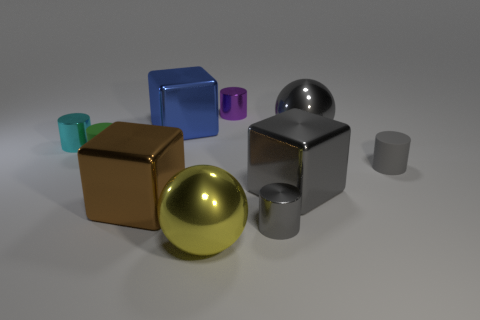There is a big shiny cube that is on the right side of the purple cylinder; does it have the same color as the small shiny thing that is right of the small purple object?
Provide a succinct answer. Yes. Is the big blue metallic object the same shape as the brown thing?
Ensure brevity in your answer.  Yes. Is the material of the big ball in front of the gray metallic sphere the same as the large brown block?
Offer a very short reply. Yes. There is a tiny metal thing that is to the right of the tiny green matte cylinder and in front of the purple metallic cylinder; what shape is it?
Provide a short and direct response. Cylinder. There is a tiny rubber cylinder that is right of the yellow object; are there any metal balls that are behind it?
Ensure brevity in your answer.  Yes. How many other things are the same material as the brown thing?
Make the answer very short. 7. There is a tiny gray thing that is right of the gray cube; is it the same shape as the small thing that is behind the tiny cyan object?
Make the answer very short. Yes. Is the big gray block made of the same material as the large yellow thing?
Give a very brief answer. Yes. There is a blue shiny object behind the shiny ball that is to the right of the big ball that is in front of the brown metallic block; what size is it?
Your answer should be compact. Large. The yellow thing that is the same size as the gray ball is what shape?
Provide a short and direct response. Sphere. 